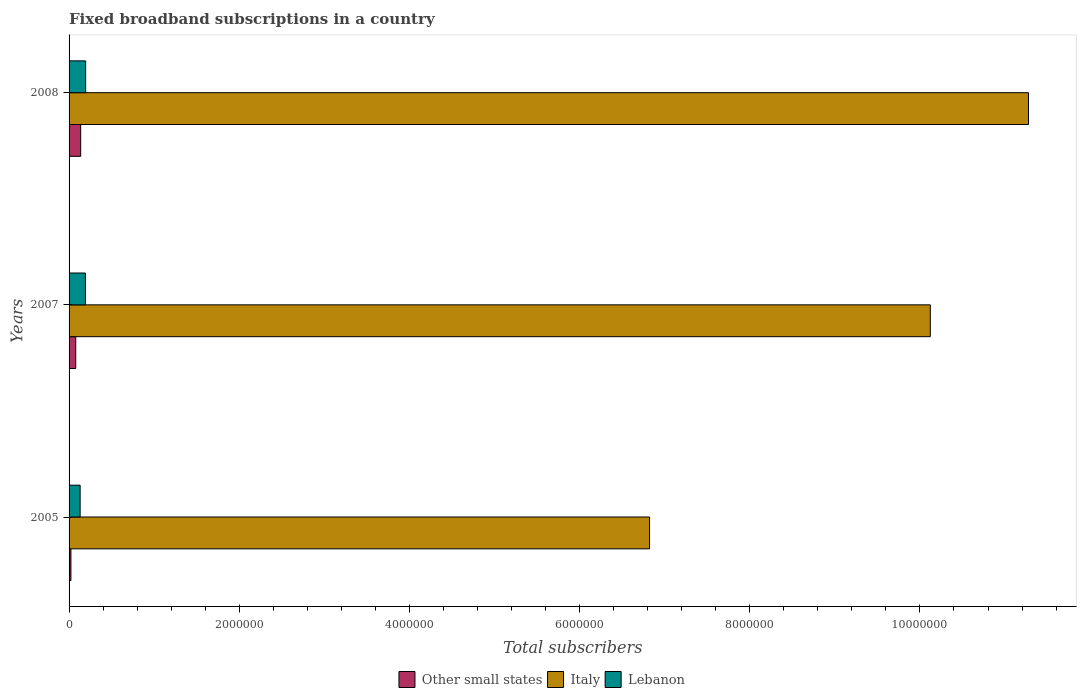How many groups of bars are there?
Provide a short and direct response. 3. Are the number of bars on each tick of the Y-axis equal?
Offer a very short reply. Yes. How many bars are there on the 1st tick from the bottom?
Your answer should be very brief. 3. What is the label of the 1st group of bars from the top?
Your answer should be compact. 2008. In how many cases, is the number of bars for a given year not equal to the number of legend labels?
Provide a short and direct response. 0. What is the number of broadband subscriptions in Lebanon in 2008?
Offer a terse response. 1.95e+05. Across all years, what is the maximum number of broadband subscriptions in Lebanon?
Give a very brief answer. 1.95e+05. Across all years, what is the minimum number of broadband subscriptions in Other small states?
Ensure brevity in your answer.  2.18e+04. In which year was the number of broadband subscriptions in Lebanon maximum?
Provide a succinct answer. 2008. What is the total number of broadband subscriptions in Other small states in the graph?
Provide a short and direct response. 2.37e+05. What is the difference between the number of broadband subscriptions in Lebanon in 2005 and that in 2008?
Your response must be concise. -6.50e+04. What is the difference between the number of broadband subscriptions in Italy in 2008 and the number of broadband subscriptions in Lebanon in 2007?
Your answer should be very brief. 1.11e+07. What is the average number of broadband subscriptions in Italy per year?
Your answer should be very brief. 9.41e+06. In the year 2005, what is the difference between the number of broadband subscriptions in Lebanon and number of broadband subscriptions in Other small states?
Give a very brief answer. 1.08e+05. What is the ratio of the number of broadband subscriptions in Italy in 2005 to that in 2008?
Your response must be concise. 0.61. Is the number of broadband subscriptions in Lebanon in 2005 less than that in 2008?
Ensure brevity in your answer.  Yes. Is the difference between the number of broadband subscriptions in Lebanon in 2005 and 2007 greater than the difference between the number of broadband subscriptions in Other small states in 2005 and 2007?
Your answer should be compact. No. What is the difference between the highest and the second highest number of broadband subscriptions in Lebanon?
Give a very brief answer. 3000. What is the difference between the highest and the lowest number of broadband subscriptions in Lebanon?
Your answer should be very brief. 6.50e+04. In how many years, is the number of broadband subscriptions in Lebanon greater than the average number of broadband subscriptions in Lebanon taken over all years?
Ensure brevity in your answer.  2. What does the 1st bar from the top in 2007 represents?
Your answer should be very brief. Lebanon. What does the 2nd bar from the bottom in 2008 represents?
Ensure brevity in your answer.  Italy. How many bars are there?
Your answer should be very brief. 9. Are all the bars in the graph horizontal?
Give a very brief answer. Yes. Does the graph contain any zero values?
Ensure brevity in your answer.  No. Does the graph contain grids?
Offer a terse response. No. Where does the legend appear in the graph?
Ensure brevity in your answer.  Bottom center. How are the legend labels stacked?
Your answer should be very brief. Horizontal. What is the title of the graph?
Your answer should be very brief. Fixed broadband subscriptions in a country. What is the label or title of the X-axis?
Give a very brief answer. Total subscribers. What is the Total subscribers of Other small states in 2005?
Offer a terse response. 2.18e+04. What is the Total subscribers of Italy in 2005?
Provide a succinct answer. 6.82e+06. What is the Total subscribers in Lebanon in 2005?
Provide a short and direct response. 1.30e+05. What is the Total subscribers of Other small states in 2007?
Your response must be concise. 7.86e+04. What is the Total subscribers of Italy in 2007?
Your answer should be very brief. 1.01e+07. What is the Total subscribers of Lebanon in 2007?
Ensure brevity in your answer.  1.92e+05. What is the Total subscribers in Other small states in 2008?
Offer a very short reply. 1.36e+05. What is the Total subscribers in Italy in 2008?
Give a very brief answer. 1.13e+07. What is the Total subscribers in Lebanon in 2008?
Your answer should be very brief. 1.95e+05. Across all years, what is the maximum Total subscribers in Other small states?
Offer a terse response. 1.36e+05. Across all years, what is the maximum Total subscribers in Italy?
Keep it short and to the point. 1.13e+07. Across all years, what is the maximum Total subscribers of Lebanon?
Give a very brief answer. 1.95e+05. Across all years, what is the minimum Total subscribers in Other small states?
Your response must be concise. 2.18e+04. Across all years, what is the minimum Total subscribers in Italy?
Your answer should be compact. 6.82e+06. Across all years, what is the minimum Total subscribers in Lebanon?
Ensure brevity in your answer.  1.30e+05. What is the total Total subscribers in Other small states in the graph?
Your answer should be compact. 2.37e+05. What is the total Total subscribers of Italy in the graph?
Your answer should be very brief. 2.82e+07. What is the total Total subscribers in Lebanon in the graph?
Keep it short and to the point. 5.17e+05. What is the difference between the Total subscribers of Other small states in 2005 and that in 2007?
Your response must be concise. -5.67e+04. What is the difference between the Total subscribers in Italy in 2005 and that in 2007?
Provide a short and direct response. -3.30e+06. What is the difference between the Total subscribers in Lebanon in 2005 and that in 2007?
Keep it short and to the point. -6.20e+04. What is the difference between the Total subscribers in Other small states in 2005 and that in 2008?
Keep it short and to the point. -1.14e+05. What is the difference between the Total subscribers of Italy in 2005 and that in 2008?
Offer a terse response. -4.45e+06. What is the difference between the Total subscribers in Lebanon in 2005 and that in 2008?
Ensure brevity in your answer.  -6.50e+04. What is the difference between the Total subscribers of Other small states in 2007 and that in 2008?
Keep it short and to the point. -5.77e+04. What is the difference between the Total subscribers of Italy in 2007 and that in 2008?
Give a very brief answer. -1.15e+06. What is the difference between the Total subscribers of Lebanon in 2007 and that in 2008?
Your answer should be very brief. -3000. What is the difference between the Total subscribers of Other small states in 2005 and the Total subscribers of Italy in 2007?
Give a very brief answer. -1.01e+07. What is the difference between the Total subscribers of Other small states in 2005 and the Total subscribers of Lebanon in 2007?
Your answer should be compact. -1.70e+05. What is the difference between the Total subscribers of Italy in 2005 and the Total subscribers of Lebanon in 2007?
Your answer should be very brief. 6.63e+06. What is the difference between the Total subscribers in Other small states in 2005 and the Total subscribers in Italy in 2008?
Keep it short and to the point. -1.13e+07. What is the difference between the Total subscribers of Other small states in 2005 and the Total subscribers of Lebanon in 2008?
Provide a succinct answer. -1.73e+05. What is the difference between the Total subscribers of Italy in 2005 and the Total subscribers of Lebanon in 2008?
Provide a succinct answer. 6.63e+06. What is the difference between the Total subscribers of Other small states in 2007 and the Total subscribers of Italy in 2008?
Ensure brevity in your answer.  -1.12e+07. What is the difference between the Total subscribers in Other small states in 2007 and the Total subscribers in Lebanon in 2008?
Provide a succinct answer. -1.16e+05. What is the difference between the Total subscribers in Italy in 2007 and the Total subscribers in Lebanon in 2008?
Offer a very short reply. 9.93e+06. What is the average Total subscribers of Other small states per year?
Offer a very short reply. 7.89e+04. What is the average Total subscribers of Italy per year?
Ensure brevity in your answer.  9.41e+06. What is the average Total subscribers in Lebanon per year?
Provide a succinct answer. 1.72e+05. In the year 2005, what is the difference between the Total subscribers of Other small states and Total subscribers of Italy?
Give a very brief answer. -6.80e+06. In the year 2005, what is the difference between the Total subscribers in Other small states and Total subscribers in Lebanon?
Provide a succinct answer. -1.08e+05. In the year 2005, what is the difference between the Total subscribers in Italy and Total subscribers in Lebanon?
Give a very brief answer. 6.69e+06. In the year 2007, what is the difference between the Total subscribers of Other small states and Total subscribers of Italy?
Offer a terse response. -1.00e+07. In the year 2007, what is the difference between the Total subscribers of Other small states and Total subscribers of Lebanon?
Give a very brief answer. -1.13e+05. In the year 2007, what is the difference between the Total subscribers of Italy and Total subscribers of Lebanon?
Your answer should be very brief. 9.93e+06. In the year 2008, what is the difference between the Total subscribers in Other small states and Total subscribers in Italy?
Your answer should be compact. -1.11e+07. In the year 2008, what is the difference between the Total subscribers in Other small states and Total subscribers in Lebanon?
Offer a terse response. -5.87e+04. In the year 2008, what is the difference between the Total subscribers in Italy and Total subscribers in Lebanon?
Ensure brevity in your answer.  1.11e+07. What is the ratio of the Total subscribers in Other small states in 2005 to that in 2007?
Offer a very short reply. 0.28. What is the ratio of the Total subscribers of Italy in 2005 to that in 2007?
Provide a short and direct response. 0.67. What is the ratio of the Total subscribers in Lebanon in 2005 to that in 2007?
Provide a short and direct response. 0.68. What is the ratio of the Total subscribers in Other small states in 2005 to that in 2008?
Offer a terse response. 0.16. What is the ratio of the Total subscribers of Italy in 2005 to that in 2008?
Keep it short and to the point. 0.6. What is the ratio of the Total subscribers of Lebanon in 2005 to that in 2008?
Offer a very short reply. 0.67. What is the ratio of the Total subscribers in Other small states in 2007 to that in 2008?
Offer a terse response. 0.58. What is the ratio of the Total subscribers of Italy in 2007 to that in 2008?
Provide a short and direct response. 0.9. What is the ratio of the Total subscribers of Lebanon in 2007 to that in 2008?
Provide a short and direct response. 0.98. What is the difference between the highest and the second highest Total subscribers in Other small states?
Your response must be concise. 5.77e+04. What is the difference between the highest and the second highest Total subscribers of Italy?
Provide a succinct answer. 1.15e+06. What is the difference between the highest and the second highest Total subscribers of Lebanon?
Your answer should be very brief. 3000. What is the difference between the highest and the lowest Total subscribers in Other small states?
Offer a very short reply. 1.14e+05. What is the difference between the highest and the lowest Total subscribers of Italy?
Ensure brevity in your answer.  4.45e+06. What is the difference between the highest and the lowest Total subscribers in Lebanon?
Your answer should be compact. 6.50e+04. 